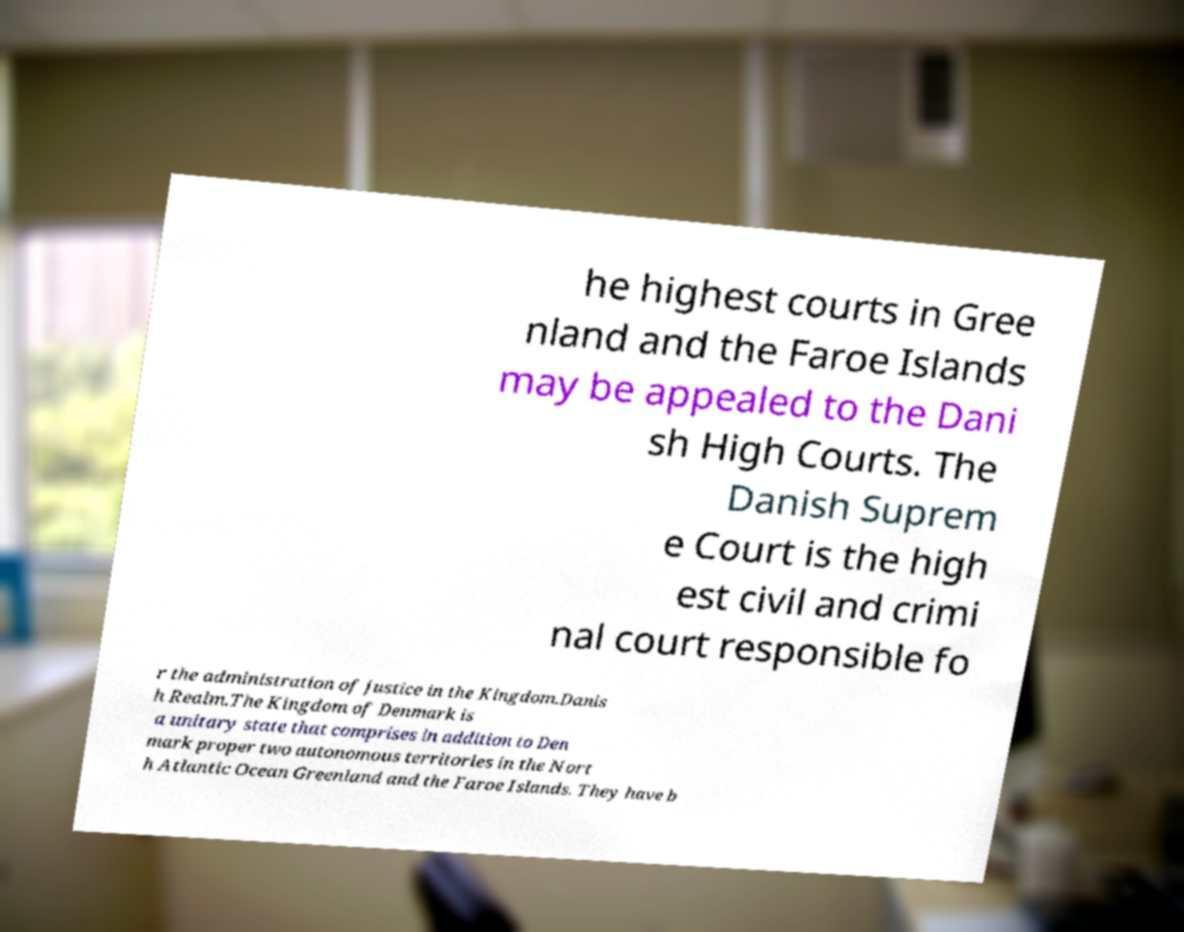What messages or text are displayed in this image? I need them in a readable, typed format. he highest courts in Gree nland and the Faroe Islands may be appealed to the Dani sh High Courts. The Danish Suprem e Court is the high est civil and crimi nal court responsible fo r the administration of justice in the Kingdom.Danis h Realm.The Kingdom of Denmark is a unitary state that comprises in addition to Den mark proper two autonomous territories in the Nort h Atlantic Ocean Greenland and the Faroe Islands. They have b 